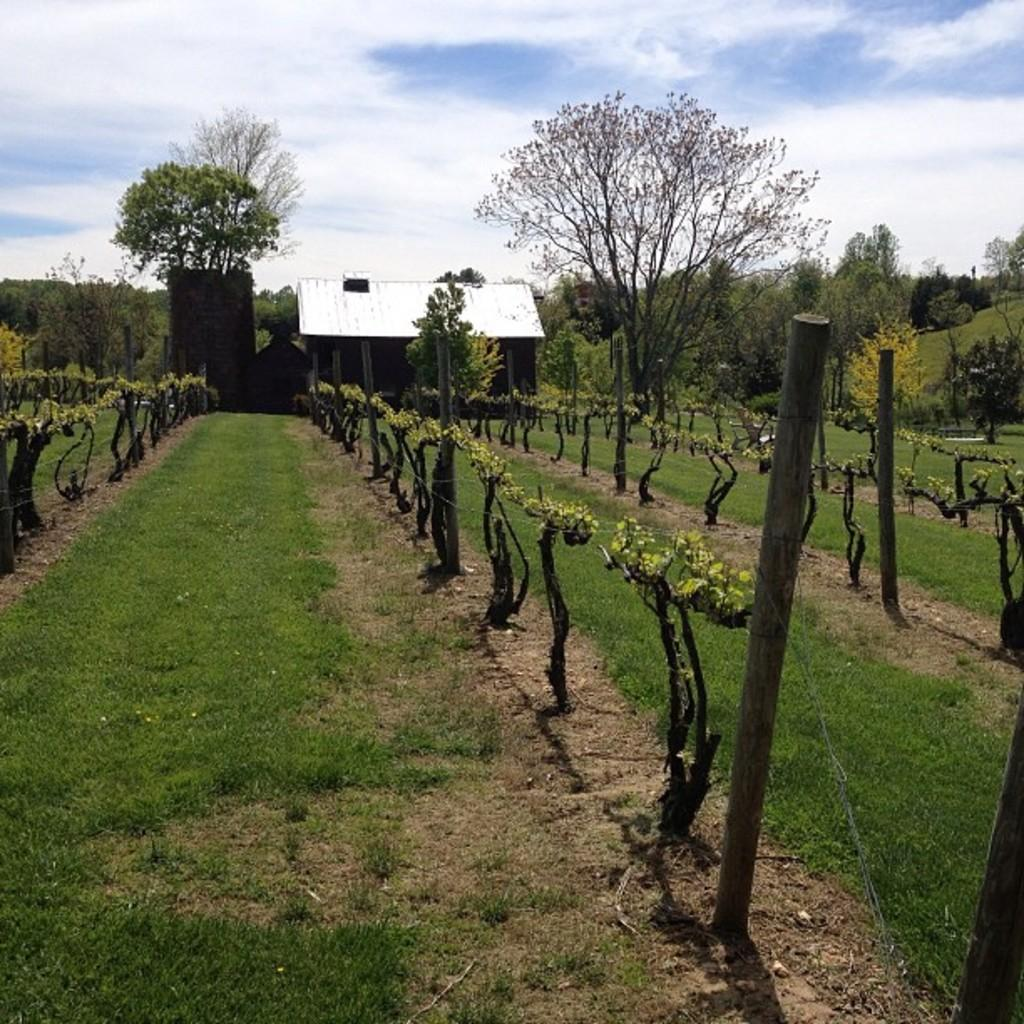What type of vegetation can be seen in the image? There are trees in the image. What type of structure is visible in the image? There is a house in the image. What are the tall, thin objects in the image? There are poles in the image. What covers the ground in the image? Grass is present on the ground in the image. How would you describe the sky in the image? The sky is blue and cloudy in the image. Can you see a ghost playing a guitar in the image? No, there is no ghost or guitar present in the image. What type of growth is visible on the trees in the image? There is no specific growth mentioned on the trees in the image; they are simply described as trees. 